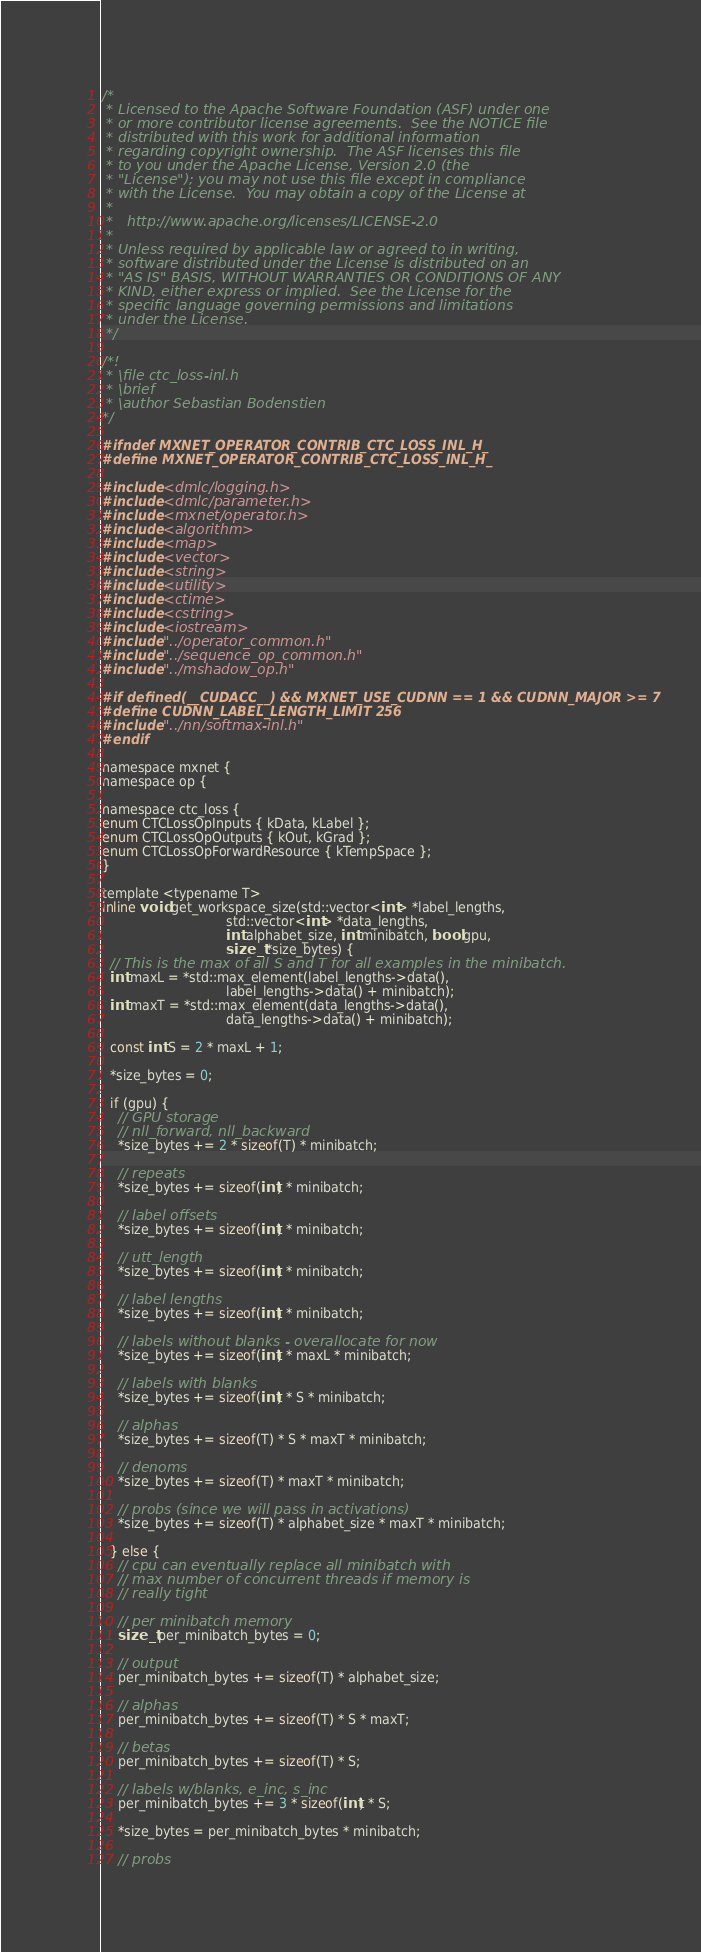<code> <loc_0><loc_0><loc_500><loc_500><_C_>/*
 * Licensed to the Apache Software Foundation (ASF) under one
 * or more contributor license agreements.  See the NOTICE file
 * distributed with this work for additional information
 * regarding copyright ownership.  The ASF licenses this file
 * to you under the Apache License, Version 2.0 (the
 * "License"); you may not use this file except in compliance
 * with the License.  You may obtain a copy of the License at
 *
 *   http://www.apache.org/licenses/LICENSE-2.0
 *
 * Unless required by applicable law or agreed to in writing,
 * software distributed under the License is distributed on an
 * "AS IS" BASIS, WITHOUT WARRANTIES OR CONDITIONS OF ANY
 * KIND, either express or implied.  See the License for the
 * specific language governing permissions and limitations
 * under the License.
 */

/*!
 * \file ctc_loss-inl.h
 * \brief
 * \author Sebastian Bodenstien
*/

#ifndef MXNET_OPERATOR_CONTRIB_CTC_LOSS_INL_H_
#define MXNET_OPERATOR_CONTRIB_CTC_LOSS_INL_H_

#include <dmlc/logging.h>
#include <dmlc/parameter.h>
#include <mxnet/operator.h>
#include <algorithm>
#include <map>
#include <vector>
#include <string>
#include <utility>
#include <ctime>
#include <cstring>
#include <iostream>
#include "../operator_common.h"
#include "../sequence_op_common.h"
#include "../mshadow_op.h"

#if defined(__CUDACC__) && MXNET_USE_CUDNN == 1 && CUDNN_MAJOR >= 7
#define CUDNN_LABEL_LENGTH_LIMIT 256
#include "../nn/softmax-inl.h"
#endif

namespace mxnet {
namespace op {

namespace ctc_loss {
enum CTCLossOpInputs { kData, kLabel };
enum CTCLossOpOutputs { kOut, kGrad };
enum CTCLossOpForwardResource { kTempSpace };
}

template <typename T>
inline void get_workspace_size(std::vector<int> *label_lengths,
                               std::vector<int> *data_lengths,
                               int alphabet_size, int minibatch, bool gpu,
                               size_t *size_bytes) {
  // This is the max of all S and T for all examples in the minibatch.
  int maxL = *std::max_element(label_lengths->data(),
                               label_lengths->data() + minibatch);
  int maxT = *std::max_element(data_lengths->data(),
                               data_lengths->data() + minibatch);

  const int S = 2 * maxL + 1;

  *size_bytes = 0;

  if (gpu) {
    // GPU storage
    // nll_forward, nll_backward
    *size_bytes += 2 * sizeof(T) * minibatch;

    // repeats
    *size_bytes += sizeof(int) * minibatch;

    // label offsets
    *size_bytes += sizeof(int) * minibatch;

    // utt_length
    *size_bytes += sizeof(int) * minibatch;

    // label lengths
    *size_bytes += sizeof(int) * minibatch;

    // labels without blanks - overallocate for now
    *size_bytes += sizeof(int) * maxL * minibatch;

    // labels with blanks
    *size_bytes += sizeof(int) * S * minibatch;

    // alphas
    *size_bytes += sizeof(T) * S * maxT * minibatch;

    // denoms
    *size_bytes += sizeof(T) * maxT * minibatch;

    // probs (since we will pass in activations)
    *size_bytes += sizeof(T) * alphabet_size * maxT * minibatch;

  } else {
    // cpu can eventually replace all minibatch with
    // max number of concurrent threads if memory is
    // really tight

    // per minibatch memory
    size_t per_minibatch_bytes = 0;

    // output
    per_minibatch_bytes += sizeof(T) * alphabet_size;

    // alphas
    per_minibatch_bytes += sizeof(T) * S * maxT;

    // betas
    per_minibatch_bytes += sizeof(T) * S;

    // labels w/blanks, e_inc, s_inc
    per_minibatch_bytes += 3 * sizeof(int) * S;

    *size_bytes = per_minibatch_bytes * minibatch;

    // probs</code> 